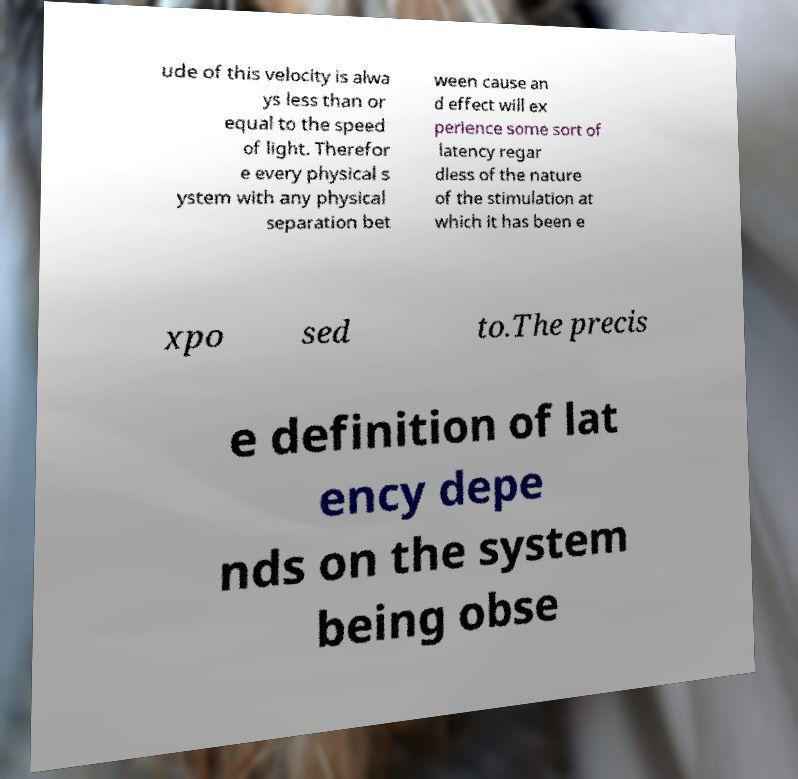For documentation purposes, I need the text within this image transcribed. Could you provide that? ude of this velocity is alwa ys less than or equal to the speed of light. Therefor e every physical s ystem with any physical separation bet ween cause an d effect will ex perience some sort of latency regar dless of the nature of the stimulation at which it has been e xpo sed to.The precis e definition of lat ency depe nds on the system being obse 